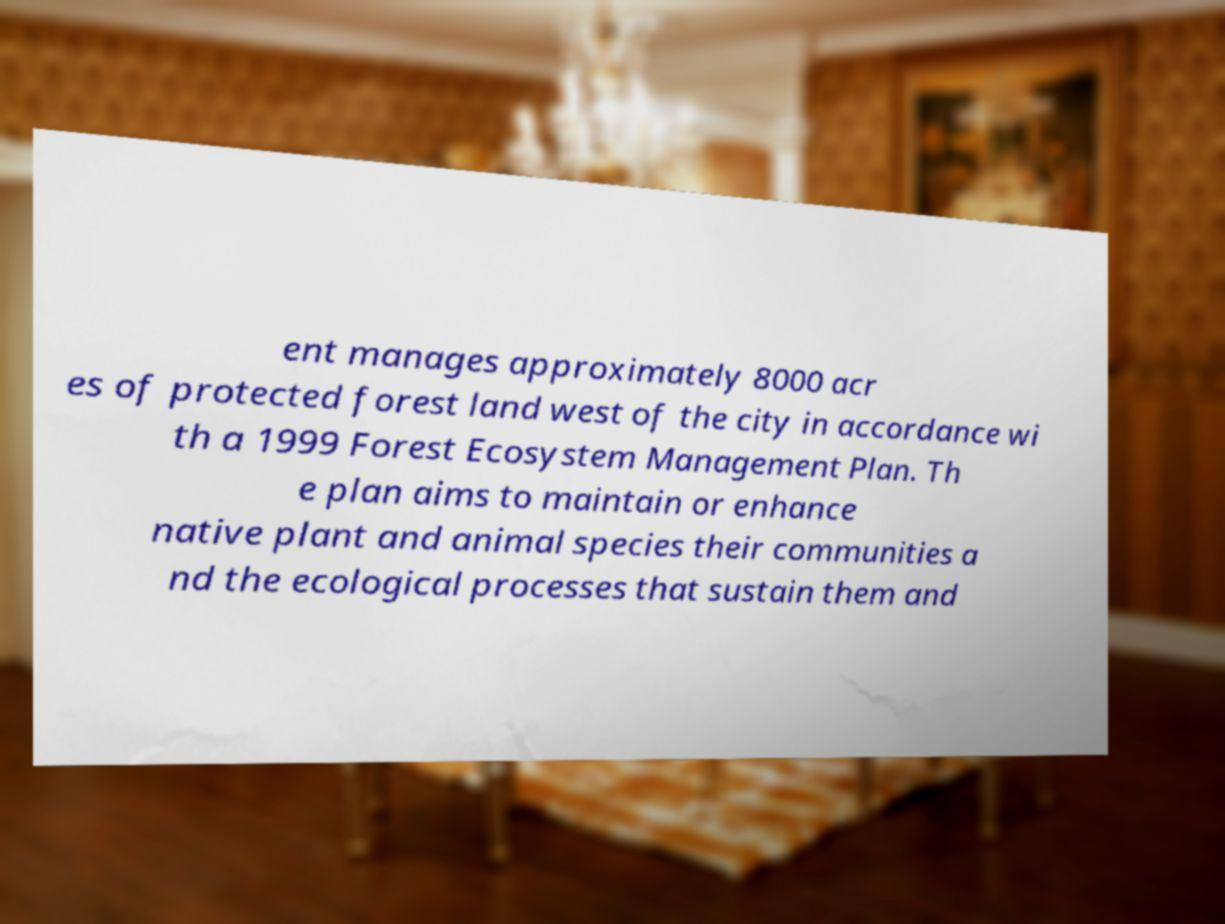Could you assist in decoding the text presented in this image and type it out clearly? ent manages approximately 8000 acr es of protected forest land west of the city in accordance wi th a 1999 Forest Ecosystem Management Plan. Th e plan aims to maintain or enhance native plant and animal species their communities a nd the ecological processes that sustain them and 